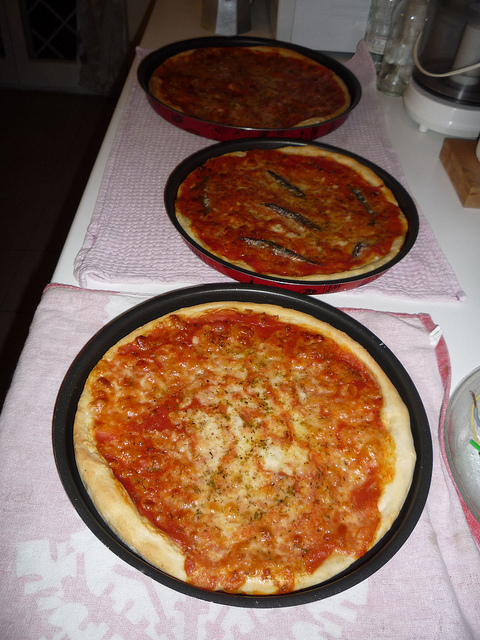<image>Is the towel in front upside down? I don't know if the towel in front is upside down. Both options 'yes' and 'no' are possible. What design does the tablecloth have? It is ambiguous what design the tablecloth has. It could be solid, floral, plain, checked, weaved, or pink and white. Is the towel in front upside down? I don't know if the towel in front is upside down or not. What design does the tablecloth have? It is unknown what design the tablecloth has. However, it can be seen as solid, floral, or plain. 